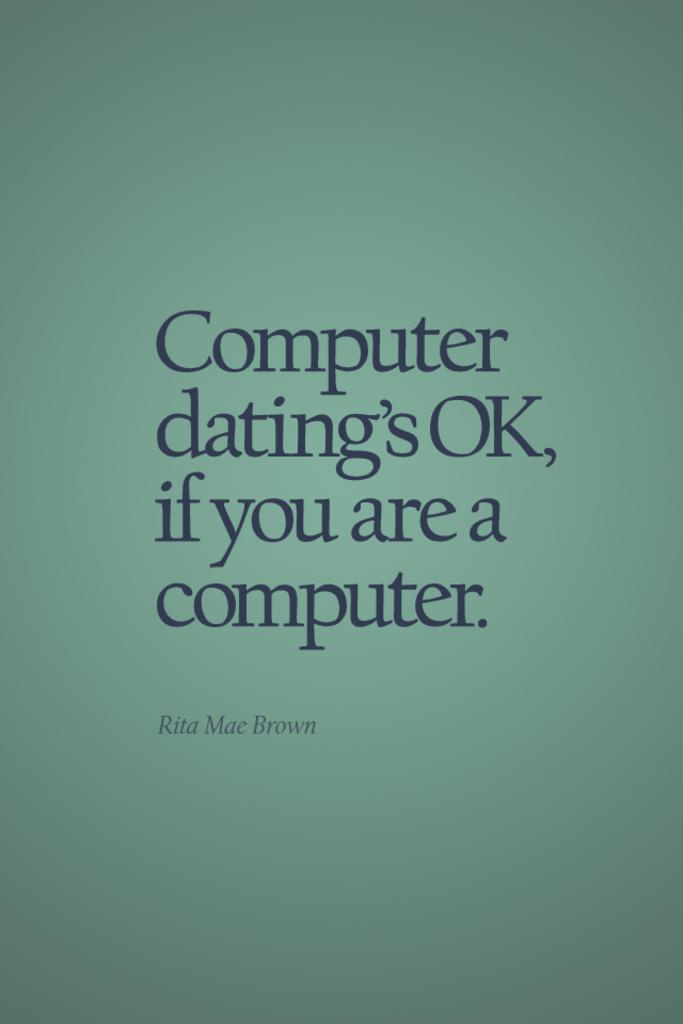<image>
Share a concise interpretation of the image provided. A green cover of a book that is written by Rita Mac Brown. 